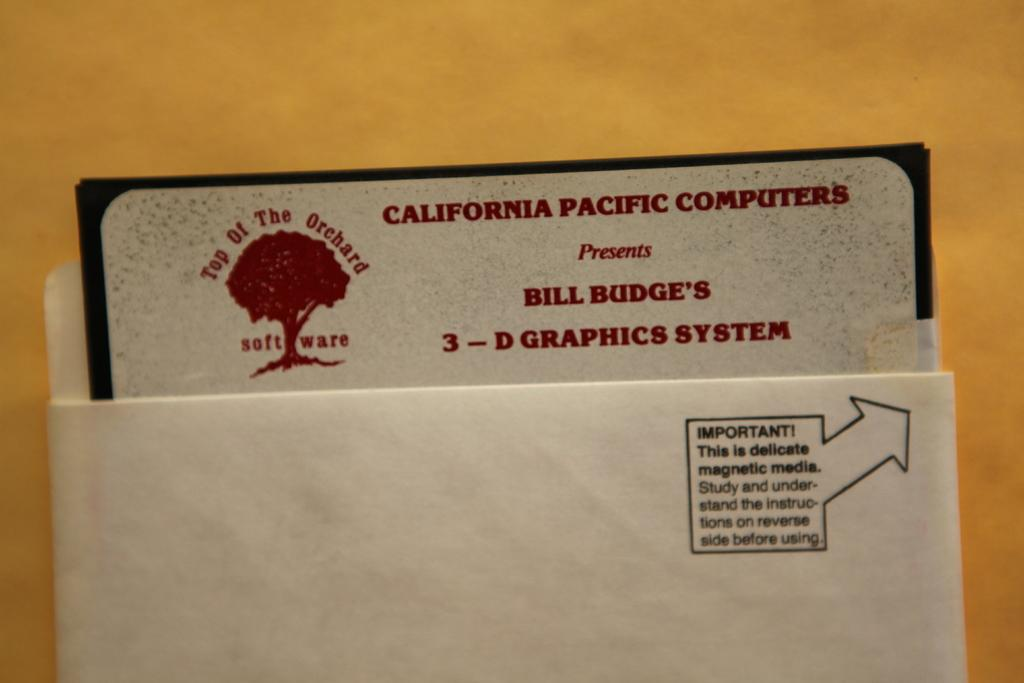<image>
Summarize the visual content of the image. A small envelope containing a card from California Pacific computers. 